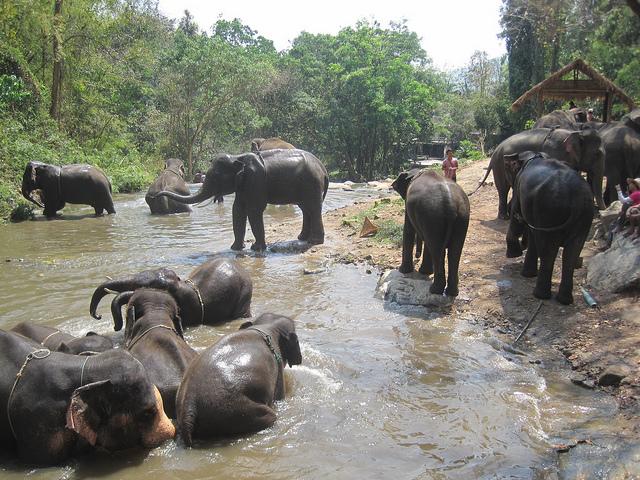Are these hippos?
Short answer required. No. Where are the hippos?
Keep it brief. Somewhere else. Are these hippos in the water?
Concise answer only. No. 